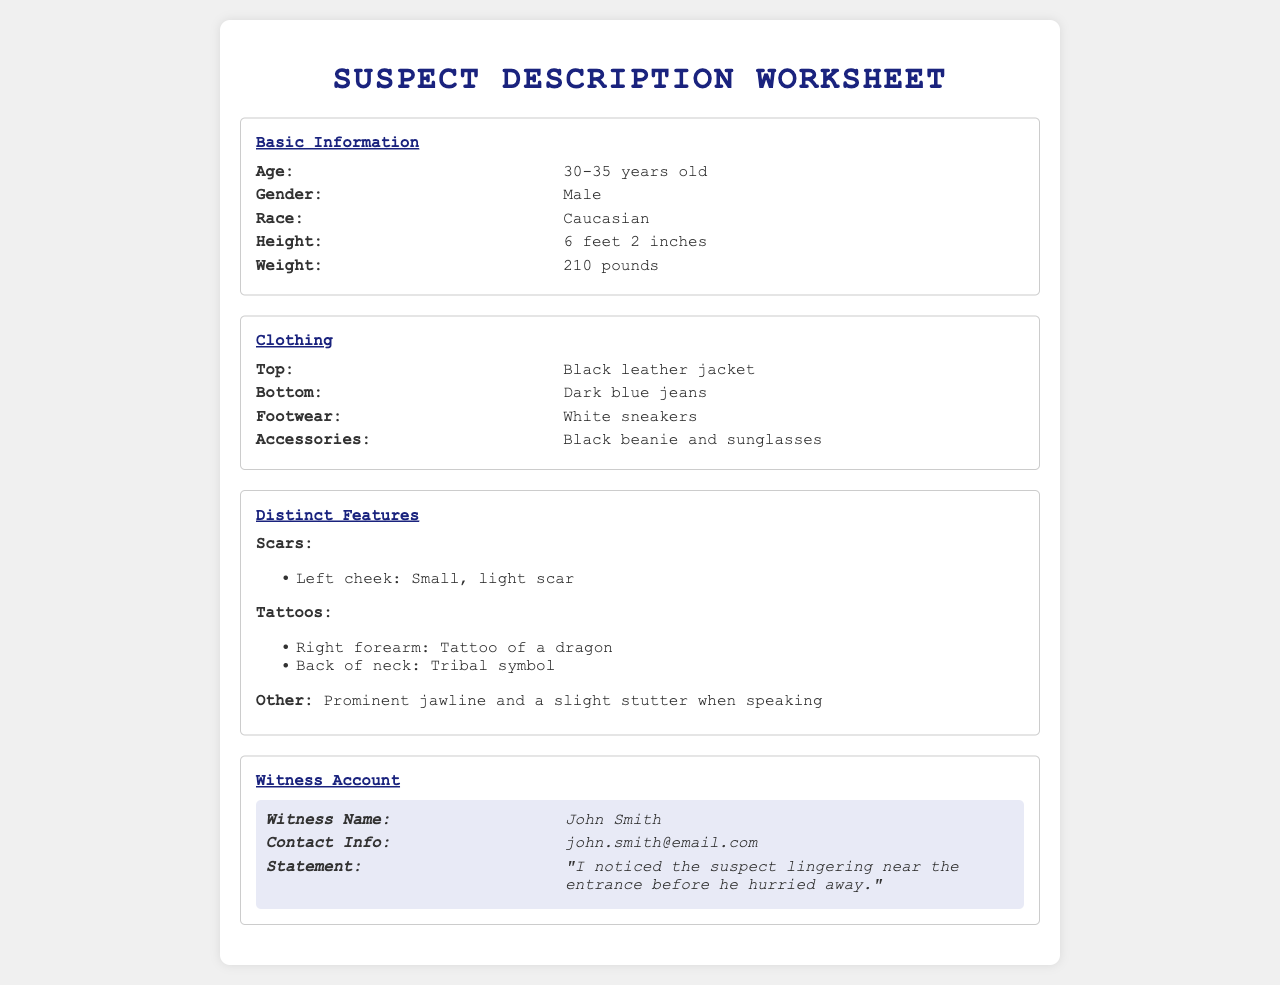What is the suspect's age range? The suspect's age is provided in a range from the witness description.
Answer: 30-35 years old What is the suspect's race? The document specifies the race of the suspect based on witness input.
Answer: Caucasian What clothing did the suspect wear on top? The form lists the clothing items worn by the suspect, including the top garment.
Answer: Black leather jacket What distinct feature does the suspect have on the left cheek? The document notes specific scars as distinct features of the suspect.
Answer: Small, light scar Who provided the witness statement? The witness's name is clearly stated in the worksheet for reference.
Answer: John Smith What is the suspect's height? The document includes the suspect's height in feet and inches.
Answer: 6 feet 2 inches What tattoo is located on the right forearm? The distinct features section lists tattoos including their locations.
Answer: Tattoo of a dragon Does the witness mention any specific behavior of the suspect? The witness statement may contain observations of the suspect's actions.
Answer: Lingering near the entrance What accessories did the suspect wear? The document lists specific accessories that help in recognizing the suspect.
Answer: Black beanie and sunglasses 